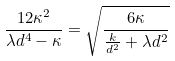Convert formula to latex. <formula><loc_0><loc_0><loc_500><loc_500>\frac { 1 2 \kappa ^ { 2 } } { \lambda d ^ { 4 } - \kappa } = \sqrt { \frac { 6 \kappa } { \frac { k } { d ^ { 2 } } + \lambda d ^ { 2 } } }</formula> 